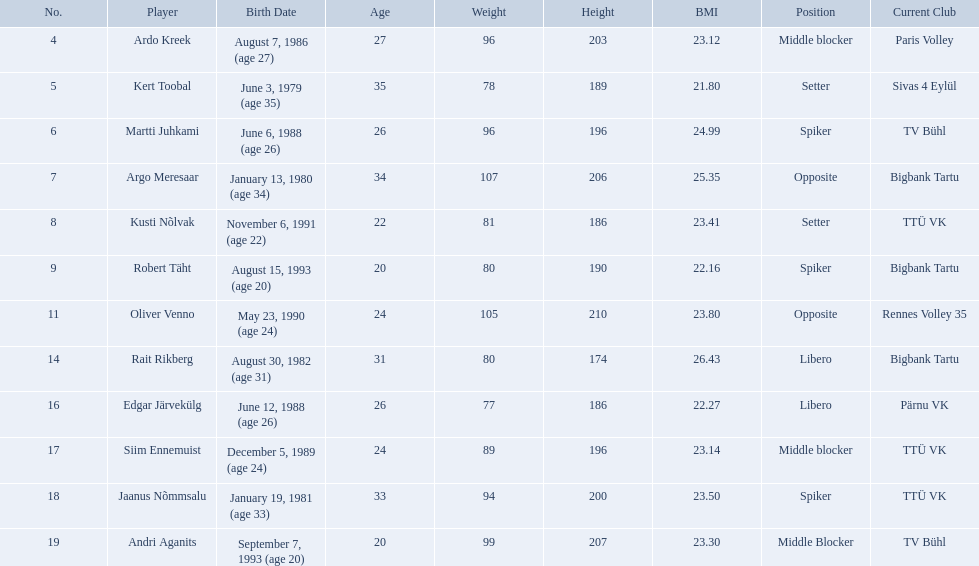Who are all of the players? Ardo Kreek, Kert Toobal, Martti Juhkami, Argo Meresaar, Kusti Nõlvak, Robert Täht, Oliver Venno, Rait Rikberg, Edgar Järvekülg, Siim Ennemuist, Jaanus Nõmmsalu, Andri Aganits. How tall are they? 203, 189, 196, 206, 186, 190, 210, 174, 186, 196, 200, 207. And which player is tallest? Oliver Venno. 